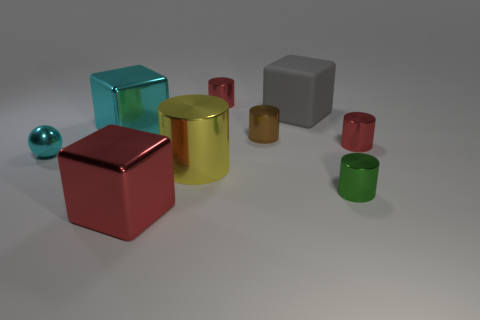Add 1 green shiny cubes. How many objects exist? 10 Subtract all large shiny blocks. How many blocks are left? 1 Subtract 1 spheres. How many spheres are left? 0 Subtract all blue cylinders. Subtract all blue blocks. How many cylinders are left? 5 Subtract all blue cubes. How many yellow balls are left? 0 Subtract all brown metallic cylinders. Subtract all big cubes. How many objects are left? 5 Add 1 tiny objects. How many tiny objects are left? 6 Add 8 cyan spheres. How many cyan spheres exist? 9 Subtract all green cylinders. How many cylinders are left? 4 Subtract 0 blue cubes. How many objects are left? 9 